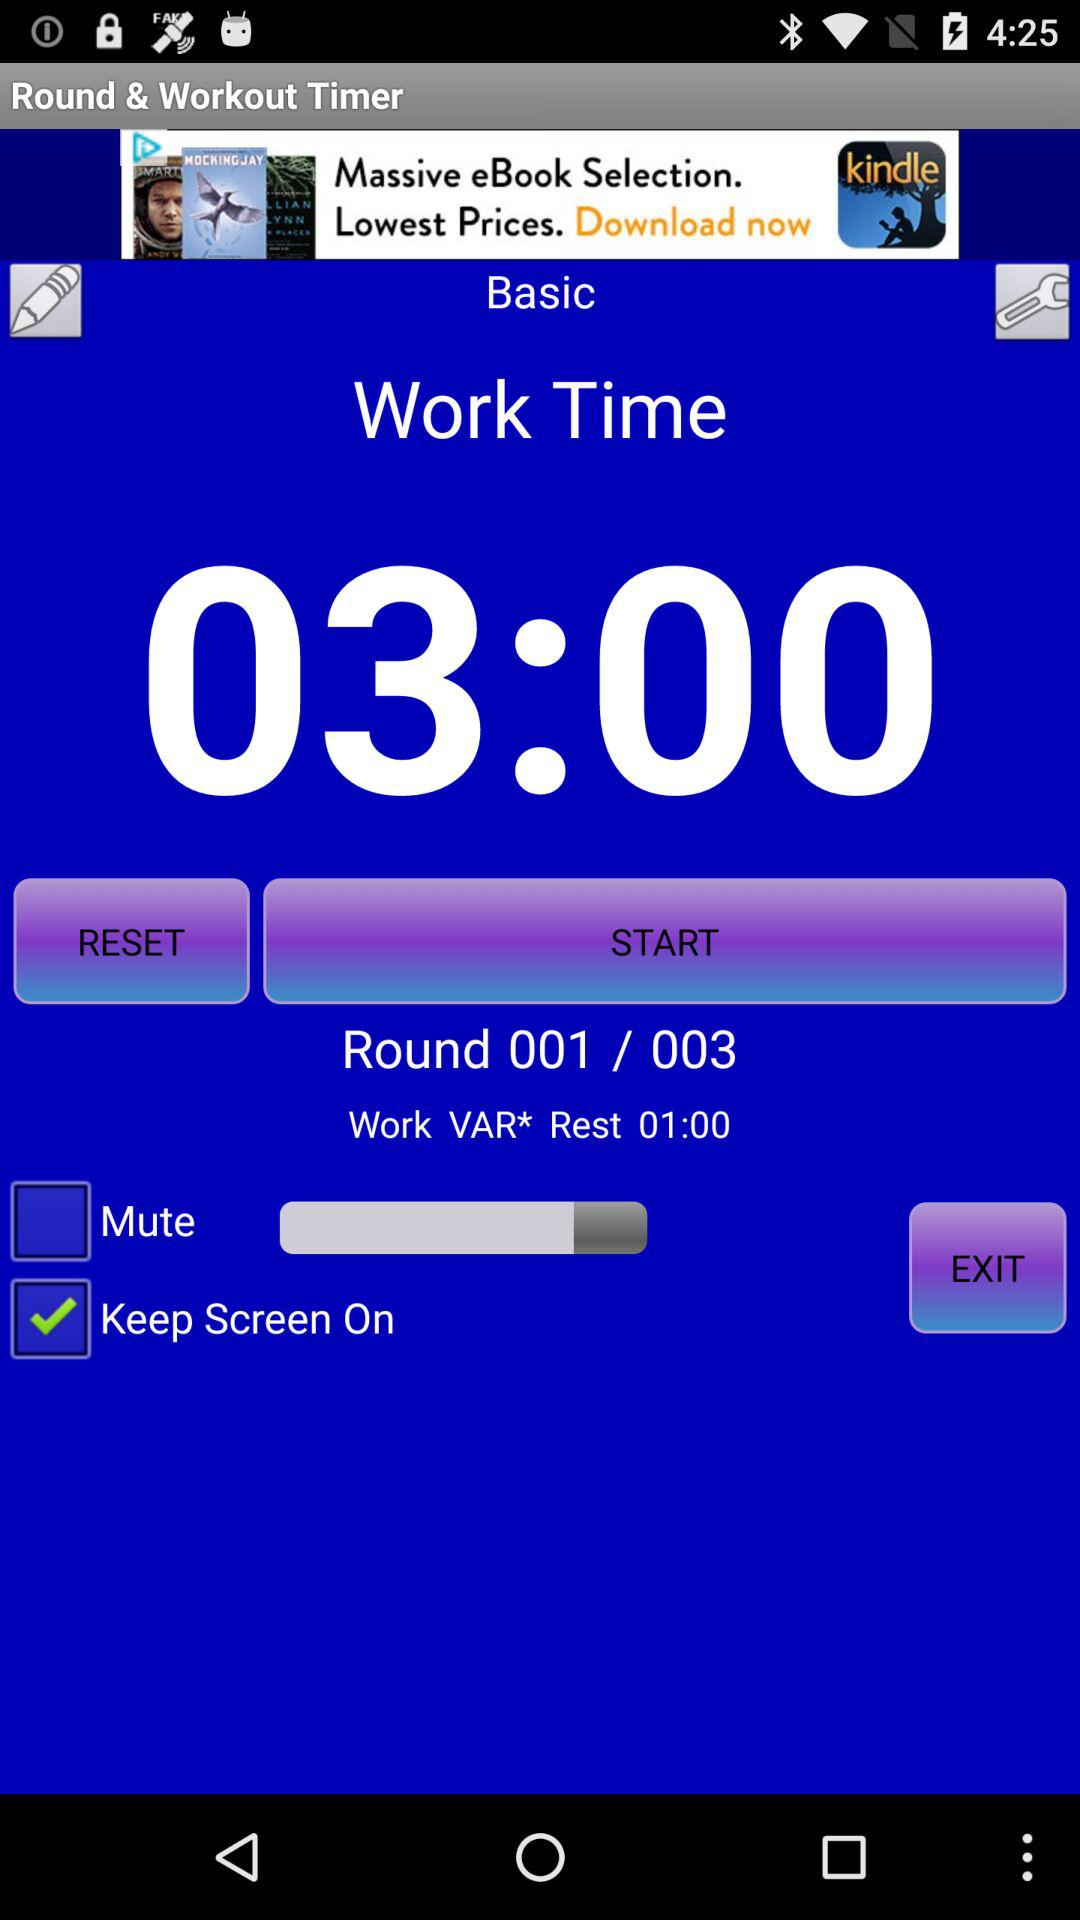What is the name of the application? The name of the application is "Round & Workout Timer". 